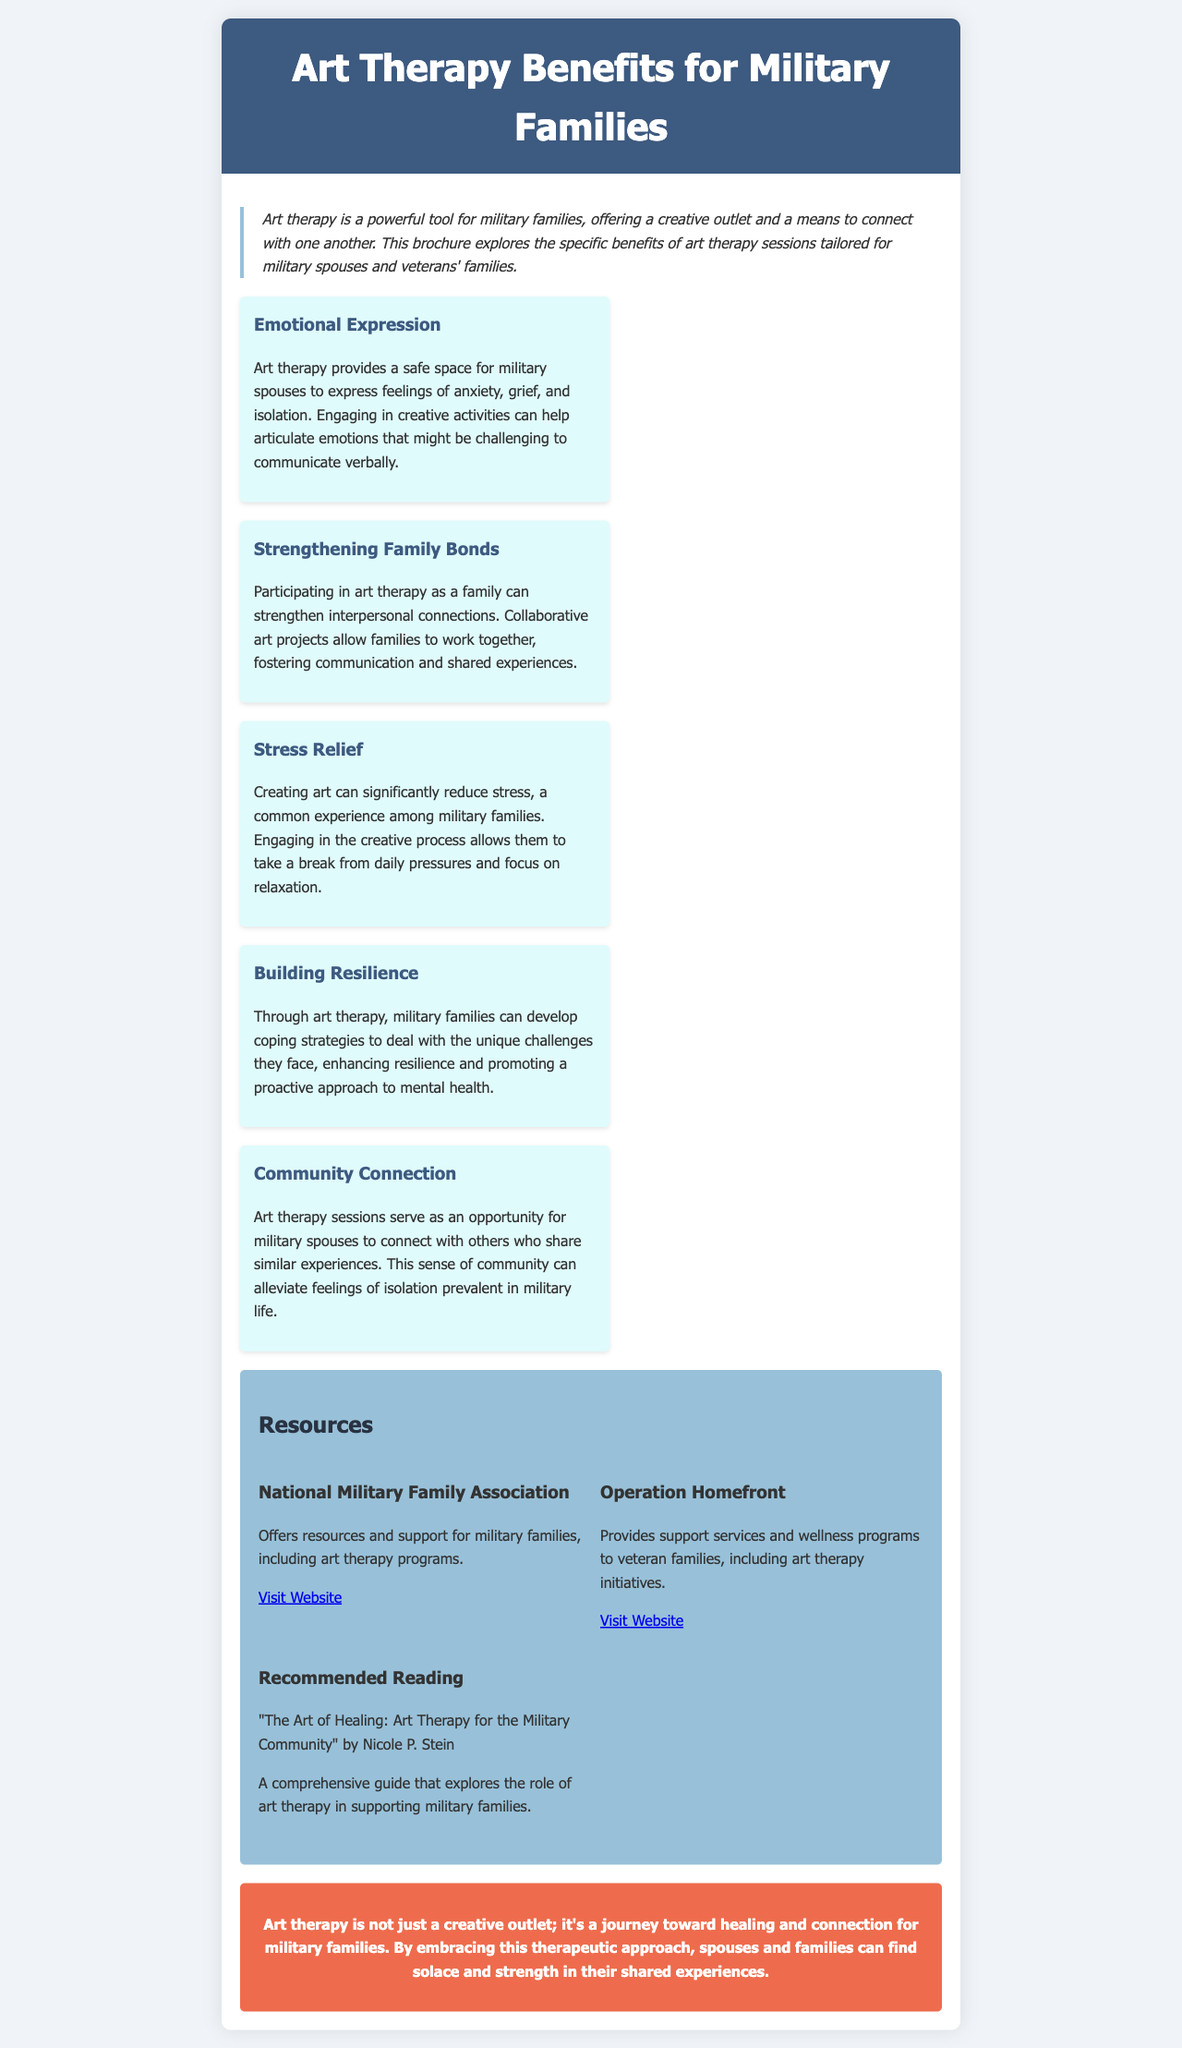what is the title of the brochure? The title of the brochure is prominently displayed at the top of the document.
Answer: Art Therapy Benefits for Military Families what is one benefit of art therapy for military families? The document lists several benefits; one example can be found in the section on emotional expression.
Answer: Emotional Expression which organization offers resources for military families? The brochure lists various resources, one of which is the National Military Family Association.
Answer: National Military Family Association how does art therapy help military spouses? The brochure states that art therapy helps with the expression of complex emotions like anxiety and grief.
Answer: Express feelings of anxiety, grief, and isolation what does collaborative art projects promote among families? The brochure explains that participating in art therapy fosters interpersonal connections among families.
Answer: Strengthening Family Bonds how many resources are listed in the brochure? The brochure features a specific section for resources detailing three organizations or initiatives.
Answer: Three what is said about creating art in terms of stress? The document mentions that creating art can significantly reduce stress for military families.
Answer: Significantly reduce stress who is the author of the recommended reading? The brochure provides a specific title and author for recommended reading associated with art therapy.
Answer: Nicole P. Stein what is the main purpose of art therapy highlighted in the brochure? The conclusion of the brochure summarizes the overall goal of art therapy for military families.
Answer: Healing and connection 